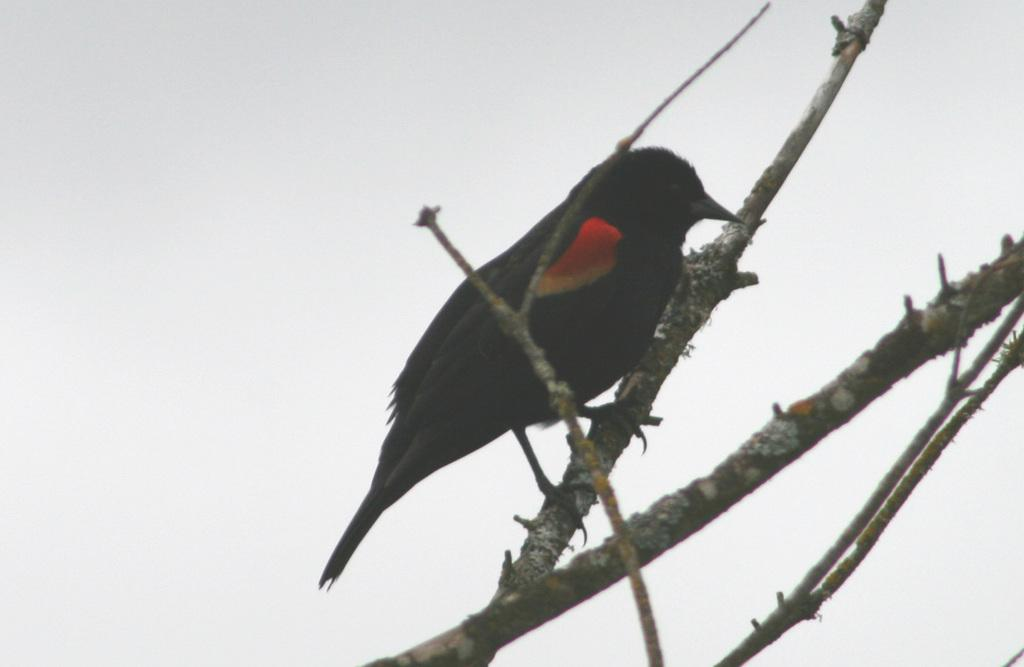What type of animal can be seen in the image? There is a bird in the image. Where is the bird located in the image? The bird is sitting on a branch. How many snails can be seen crawling on the branch in the image? There are no snails present in the image; it features a bird sitting on a branch. What type of hook is visible in the image? There is no hook present in the image. 